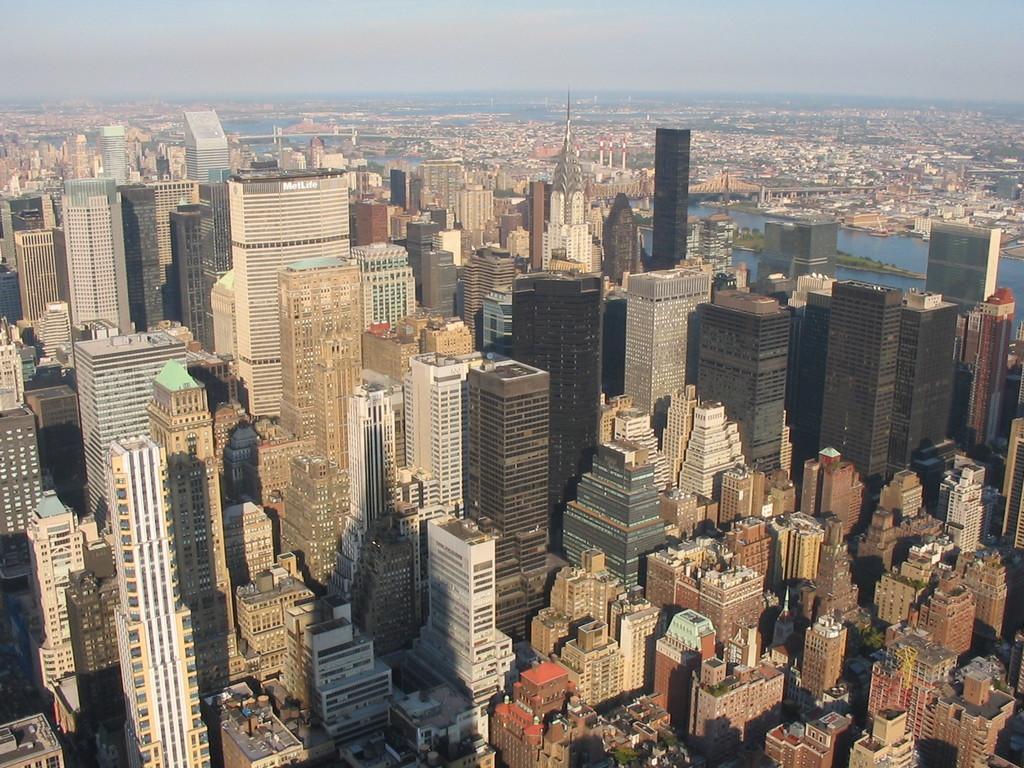How would you summarize this image in a sentence or two? In this image, we can see buildings. There is a river on the right side of the image. There is sky at the top of the image. 